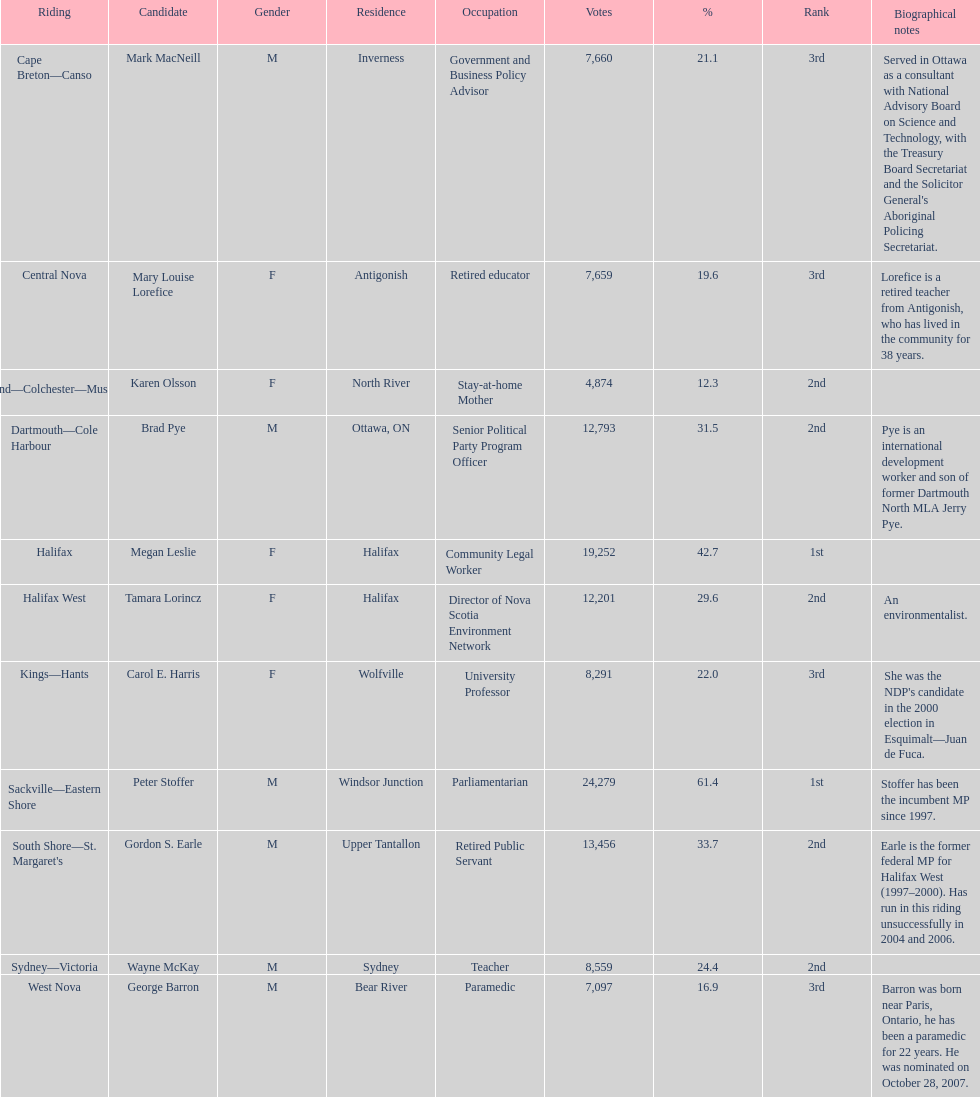What is the total number of candidates? 11. 